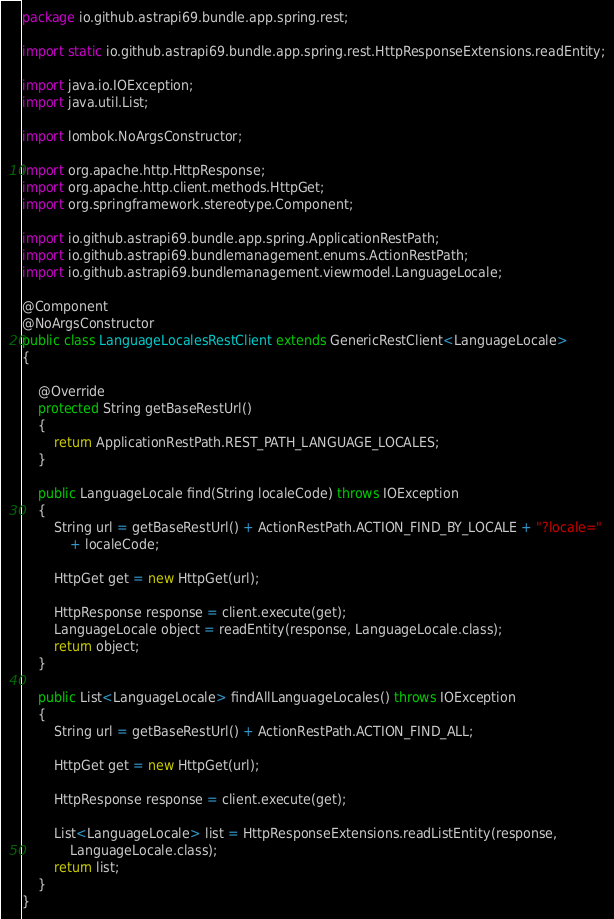Convert code to text. <code><loc_0><loc_0><loc_500><loc_500><_Java_>package io.github.astrapi69.bundle.app.spring.rest;

import static io.github.astrapi69.bundle.app.spring.rest.HttpResponseExtensions.readEntity;

import java.io.IOException;
import java.util.List;

import lombok.NoArgsConstructor;

import org.apache.http.HttpResponse;
import org.apache.http.client.methods.HttpGet;
import org.springframework.stereotype.Component;

import io.github.astrapi69.bundle.app.spring.ApplicationRestPath;
import io.github.astrapi69.bundlemanagement.enums.ActionRestPath;
import io.github.astrapi69.bundlemanagement.viewmodel.LanguageLocale;

@Component
@NoArgsConstructor
public class LanguageLocalesRestClient extends GenericRestClient<LanguageLocale>
{

	@Override
	protected String getBaseRestUrl()
	{
		return ApplicationRestPath.REST_PATH_LANGUAGE_LOCALES;
	}

	public LanguageLocale find(String localeCode) throws IOException
	{
		String url = getBaseRestUrl() + ActionRestPath.ACTION_FIND_BY_LOCALE + "?locale="
			+ localeCode;

		HttpGet get = new HttpGet(url);

		HttpResponse response = client.execute(get);
		LanguageLocale object = readEntity(response, LanguageLocale.class);
		return object;
	}

	public List<LanguageLocale> findAllLanguageLocales() throws IOException
	{
		String url = getBaseRestUrl() + ActionRestPath.ACTION_FIND_ALL;

		HttpGet get = new HttpGet(url);

		HttpResponse response = client.execute(get);

		List<LanguageLocale> list = HttpResponseExtensions.readListEntity(response,
			LanguageLocale.class);
		return list;
	}
}
</code> 